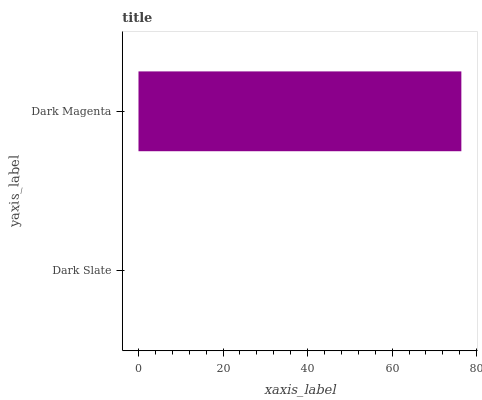Is Dark Slate the minimum?
Answer yes or no. Yes. Is Dark Magenta the maximum?
Answer yes or no. Yes. Is Dark Magenta the minimum?
Answer yes or no. No. Is Dark Magenta greater than Dark Slate?
Answer yes or no. Yes. Is Dark Slate less than Dark Magenta?
Answer yes or no. Yes. Is Dark Slate greater than Dark Magenta?
Answer yes or no. No. Is Dark Magenta less than Dark Slate?
Answer yes or no. No. Is Dark Magenta the high median?
Answer yes or no. Yes. Is Dark Slate the low median?
Answer yes or no. Yes. Is Dark Slate the high median?
Answer yes or no. No. Is Dark Magenta the low median?
Answer yes or no. No. 